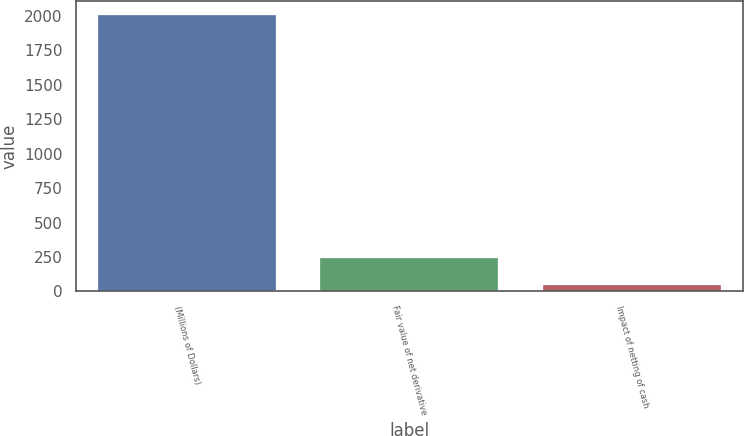<chart> <loc_0><loc_0><loc_500><loc_500><bar_chart><fcel>(Millions of Dollars)<fcel>Fair value of net derivative<fcel>Impact of netting of cash<nl><fcel>2011<fcel>242.5<fcel>46<nl></chart> 